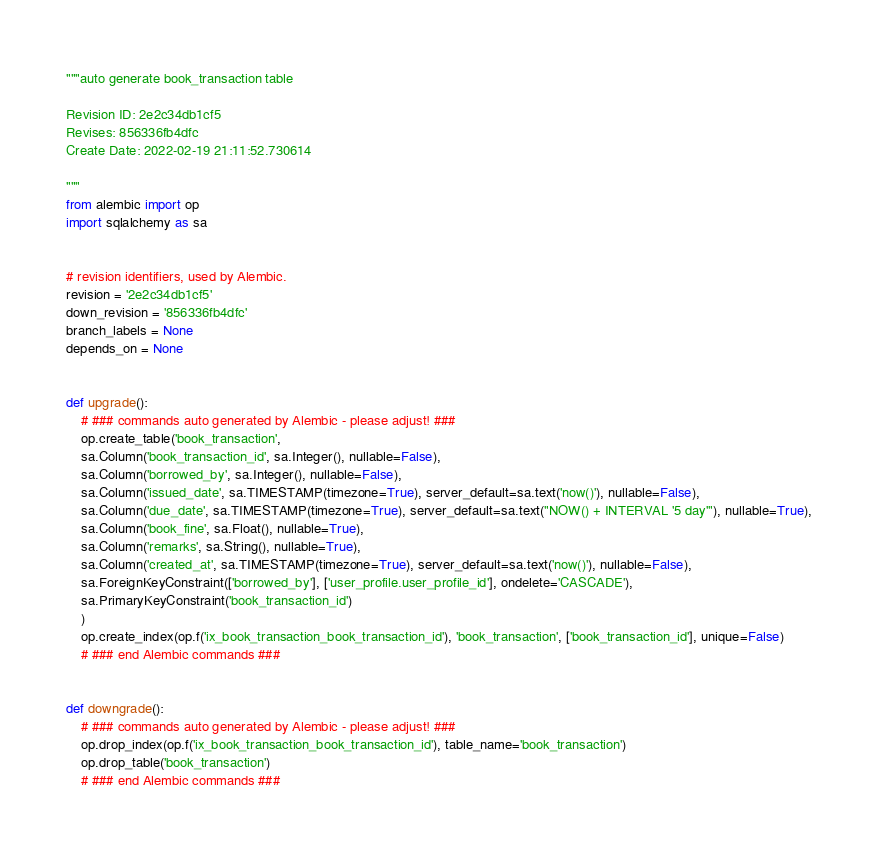<code> <loc_0><loc_0><loc_500><loc_500><_Python_>"""auto generate book_transaction table

Revision ID: 2e2c34db1cf5
Revises: 856336fb4dfc
Create Date: 2022-02-19 21:11:52.730614

"""
from alembic import op
import sqlalchemy as sa


# revision identifiers, used by Alembic.
revision = '2e2c34db1cf5'
down_revision = '856336fb4dfc'
branch_labels = None
depends_on = None


def upgrade():
    # ### commands auto generated by Alembic - please adjust! ###
    op.create_table('book_transaction',
    sa.Column('book_transaction_id', sa.Integer(), nullable=False),
    sa.Column('borrowed_by', sa.Integer(), nullable=False),
    sa.Column('issued_date', sa.TIMESTAMP(timezone=True), server_default=sa.text('now()'), nullable=False),
    sa.Column('due_date', sa.TIMESTAMP(timezone=True), server_default=sa.text("NOW() + INTERVAL '5 day'"), nullable=True),
    sa.Column('book_fine', sa.Float(), nullable=True),
    sa.Column('remarks', sa.String(), nullable=True),
    sa.Column('created_at', sa.TIMESTAMP(timezone=True), server_default=sa.text('now()'), nullable=False),
    sa.ForeignKeyConstraint(['borrowed_by'], ['user_profile.user_profile_id'], ondelete='CASCADE'),
    sa.PrimaryKeyConstraint('book_transaction_id')
    )
    op.create_index(op.f('ix_book_transaction_book_transaction_id'), 'book_transaction', ['book_transaction_id'], unique=False)
    # ### end Alembic commands ###


def downgrade():
    # ### commands auto generated by Alembic - please adjust! ###
    op.drop_index(op.f('ix_book_transaction_book_transaction_id'), table_name='book_transaction')
    op.drop_table('book_transaction')
    # ### end Alembic commands ###
</code> 